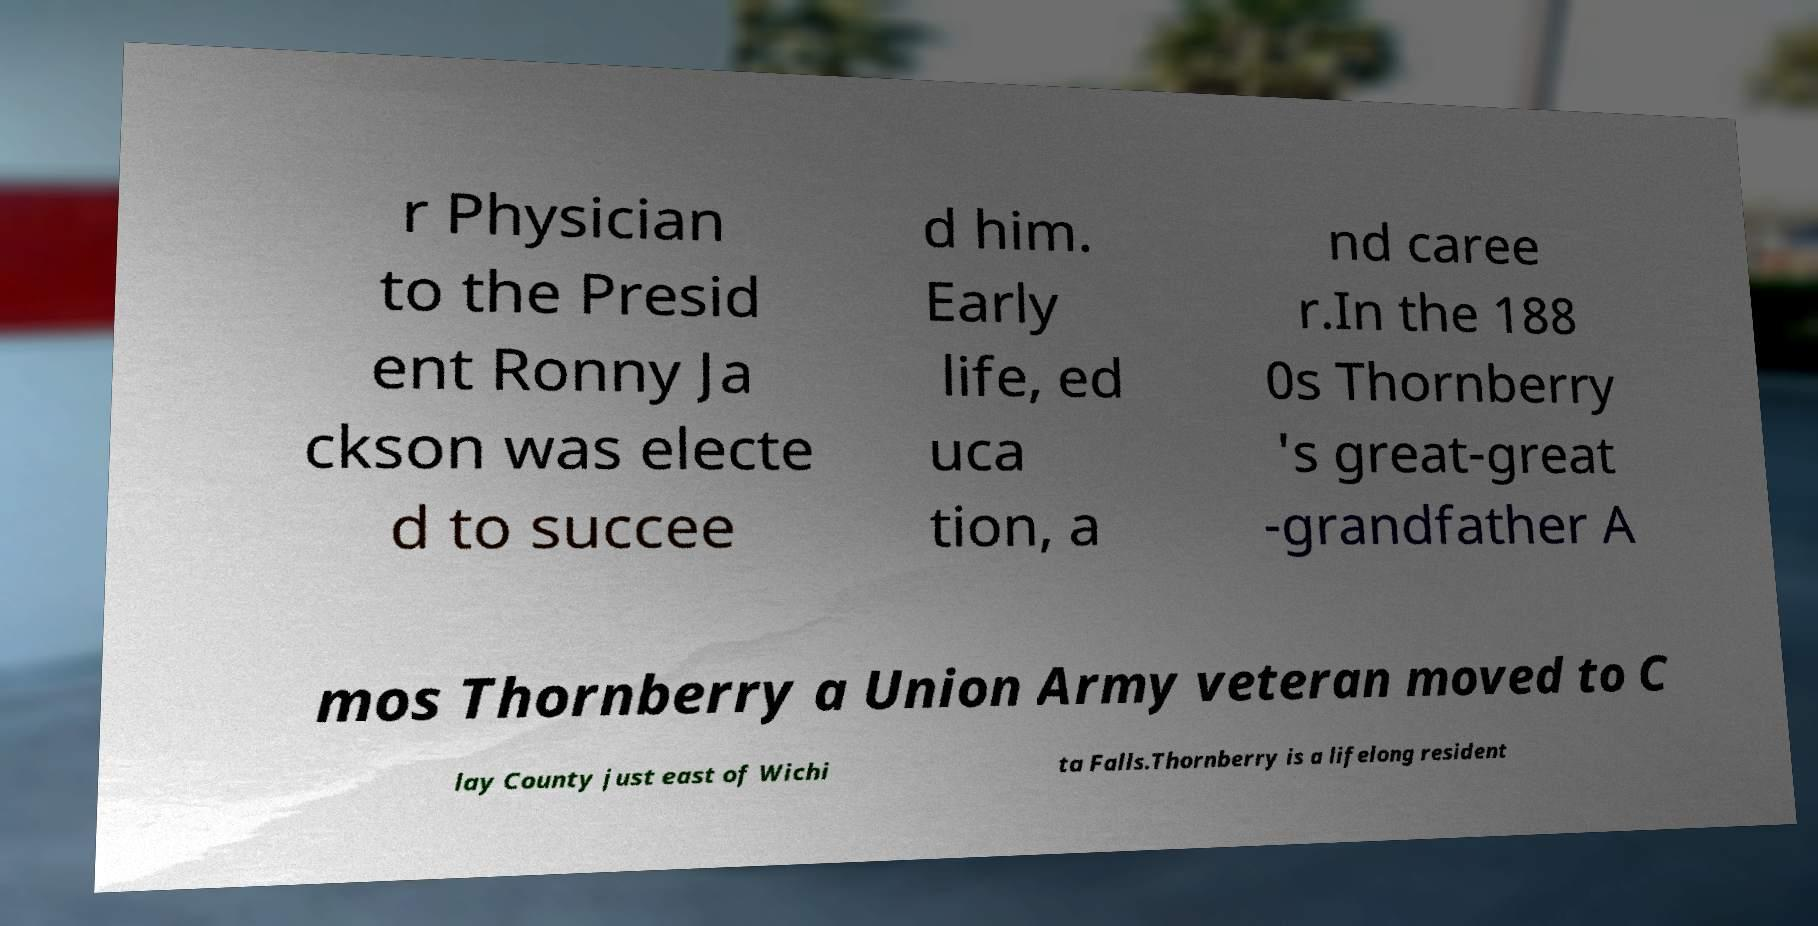There's text embedded in this image that I need extracted. Can you transcribe it verbatim? r Physician to the Presid ent Ronny Ja ckson was electe d to succee d him. Early life, ed uca tion, a nd caree r.In the 188 0s Thornberry 's great-great -grandfather A mos Thornberry a Union Army veteran moved to C lay County just east of Wichi ta Falls.Thornberry is a lifelong resident 